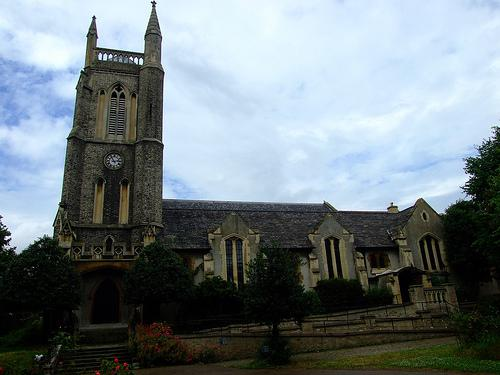Comment on the design of the wall depicted in the image. The wall in the image is artistically designed, with unique architectural elements and patterns. What type of vegetation can be seen near the church's stairs in the image? Pink flowers and red flowers can be seen near the stairs to the church. What is the main theme of this image, and what features can you point out? The main theme is architecture with a focus on buildings, windows, roofs, and doorways, as well as the presence of trees, flowers, and sky elements. Please provide a brief description of the architectural elements visible in the image. The image shows buildings with arched doorways, dark roofs, chimneys, and various sized windows, some with a narrow design, as well as towers made of stone featuring clocks and small domes. Provide a description of the buildings' roofs in the image. The buildings in the image have dark grey roofs. What is the condition of the wooden window in the scene? The wooden window in the scene is very old. For the visual entailment task, describe the scene presented in the image. The scene features various buildings with different architectural styles, windows, doors, and roofs, as well as trees, flowers, and natural elements such as clouds and blue sky. Can you identify any unique feature on a building in the image? A building in the image has a white clock and a small dome on its tower. Identify and describe the presence of any plants or trees in the image. The image features a triangular-shaped tree, trees along the wall, pink and red flowers near the stairs, and green grass on the ground. Describe the natural elements in the image, including the sky and ground. The image depicts white clouds and blue sky, with green grass on the ground. 